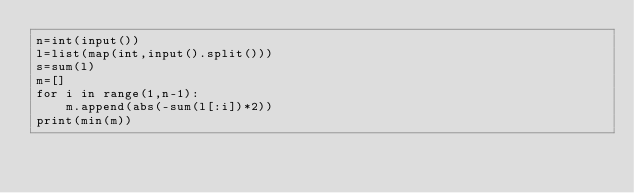Convert code to text. <code><loc_0><loc_0><loc_500><loc_500><_Python_>n=int(input())
l=list(map(int,input().split()))
s=sum(l)
m=[]
for i in range(1,n-1):
    m.append(abs(-sum(l[:i])*2))
print(min(m))</code> 